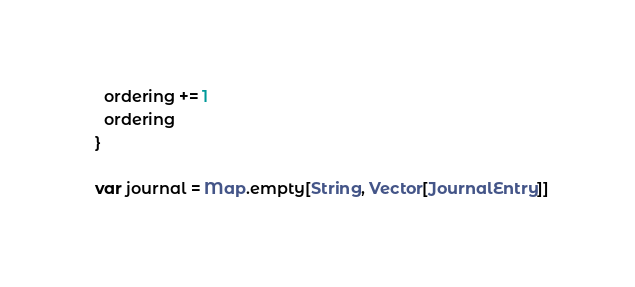Convert code to text. <code><loc_0><loc_0><loc_500><loc_500><_Scala_>    ordering += 1
    ordering
  }

  var journal = Map.empty[String, Vector[JournalEntry]]
</code> 